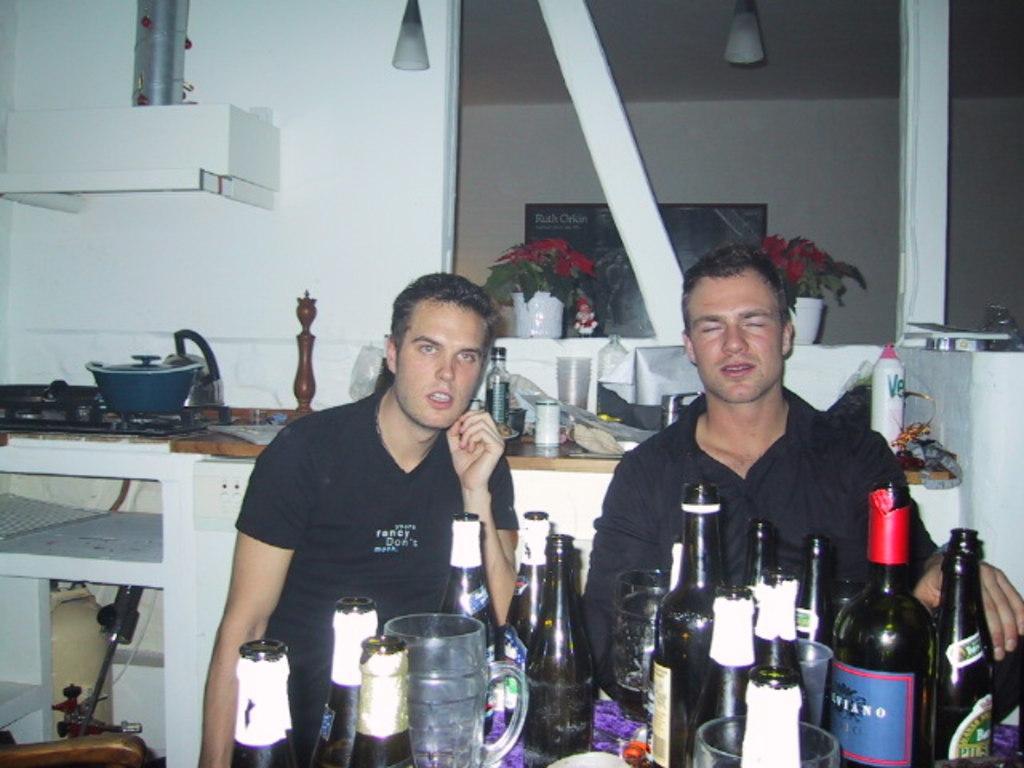In one or two sentences, can you explain what this image depicts? There are 2 men behind wine bottles. On the left there is a gas stove,dish and chimney. we can see flower vase behind them. 